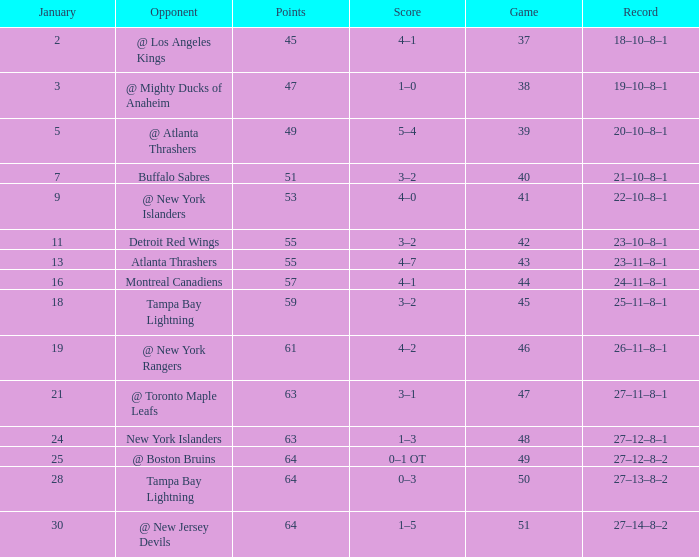How many Games have a Score of 5–4, and Points smaller than 49? 0.0. 